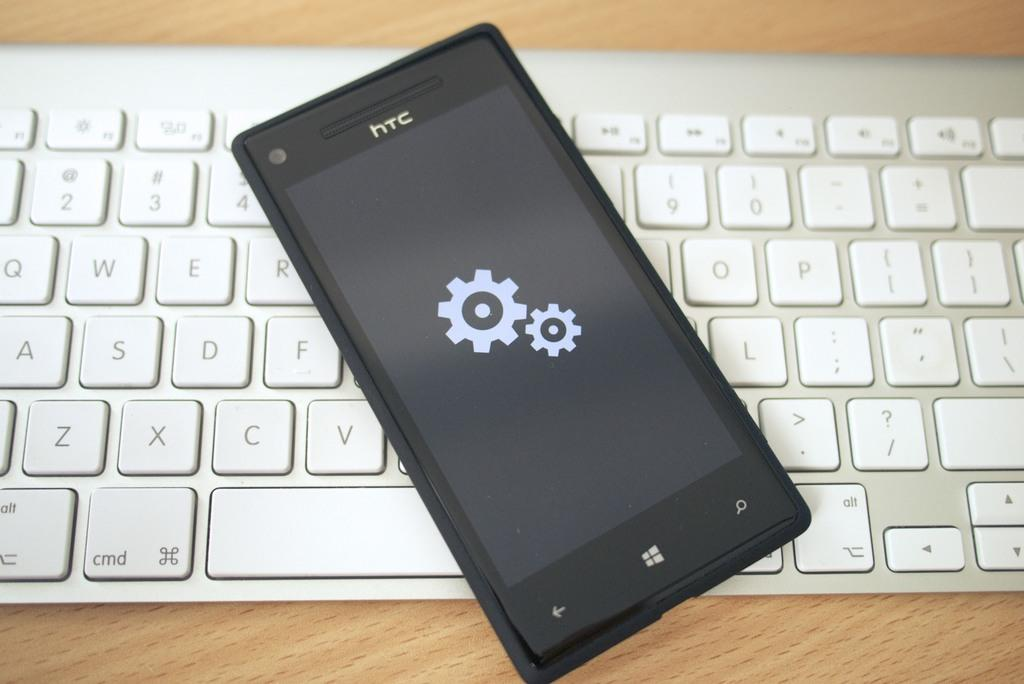What piece of furniture is present in the image? There is a table in the image. What object is placed on the table? There is a keyboard on the table. What other object is present on the table? There is a mobile on the table. What type of quill is being used to write on the keyboard in the image? There is no quill present in the image, and the keyboard is not a surface for writing with a quill. 